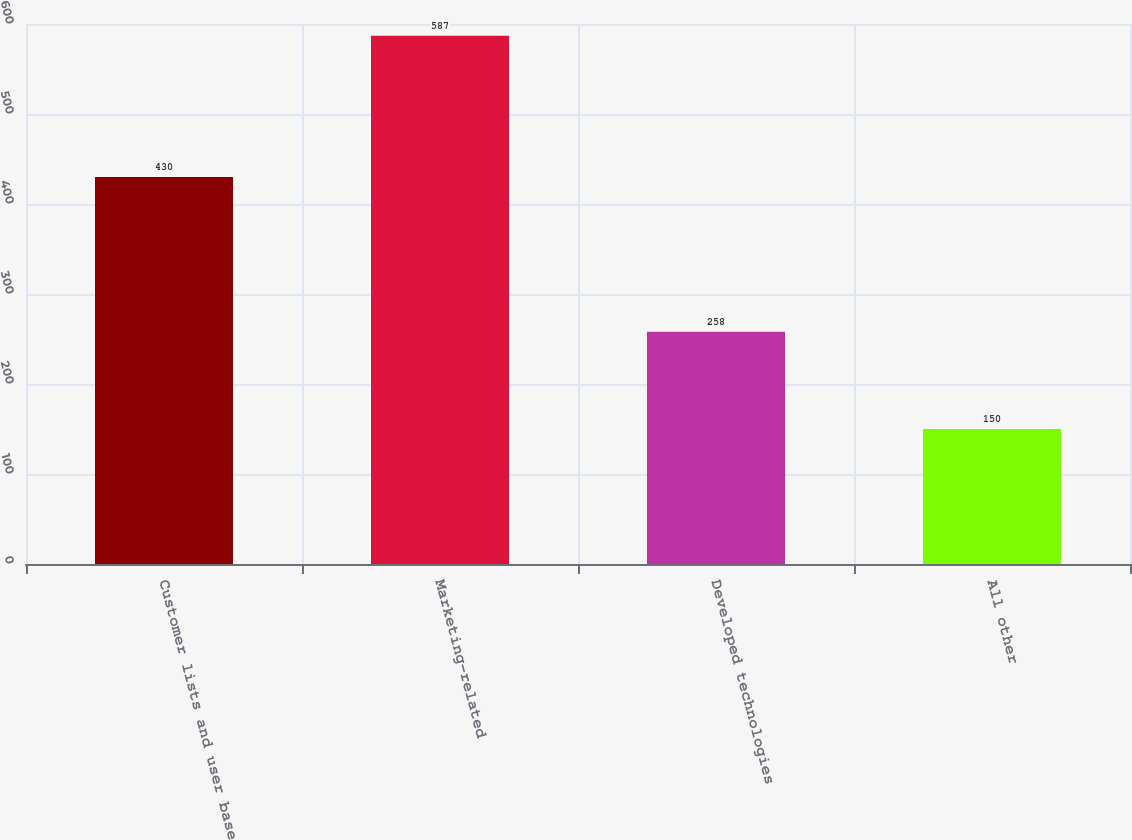Convert chart to OTSL. <chart><loc_0><loc_0><loc_500><loc_500><bar_chart><fcel>Customer lists and user base<fcel>Marketing-related<fcel>Developed technologies<fcel>All other<nl><fcel>430<fcel>587<fcel>258<fcel>150<nl></chart> 